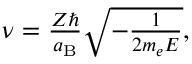<formula> <loc_0><loc_0><loc_500><loc_500>\begin{array} { r } { \nu = \frac { Z } { a _ { B } } \sqrt { - \frac { 1 } { 2 m _ { e } E } } , } \end{array}</formula> 